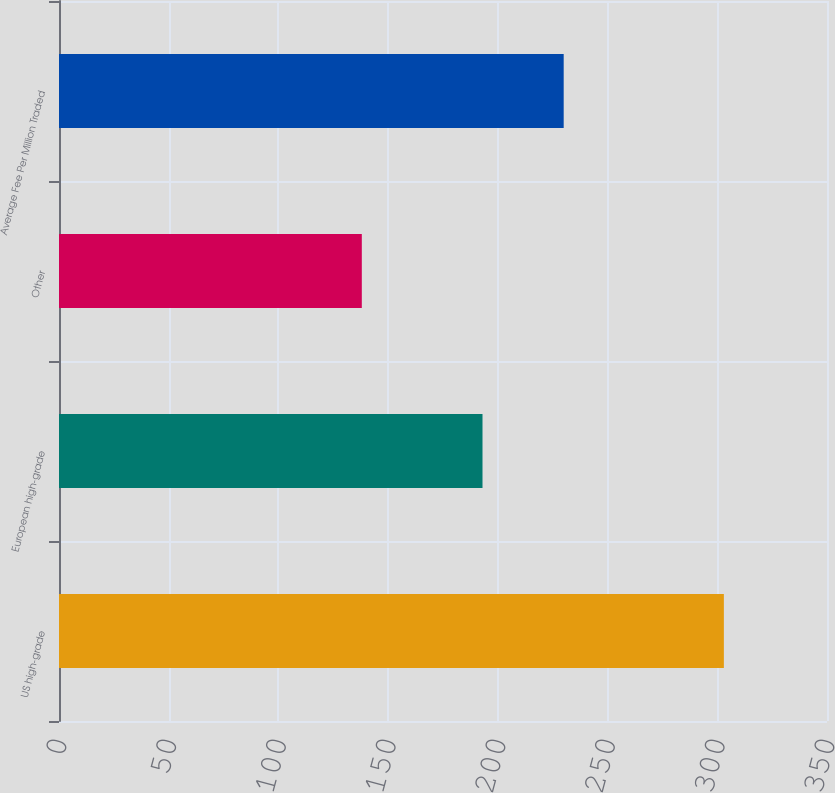Convert chart. <chart><loc_0><loc_0><loc_500><loc_500><bar_chart><fcel>US high-grade<fcel>European high-grade<fcel>Other<fcel>Average Fee Per Million Traded<nl><fcel>303<fcel>193<fcel>138<fcel>230<nl></chart> 